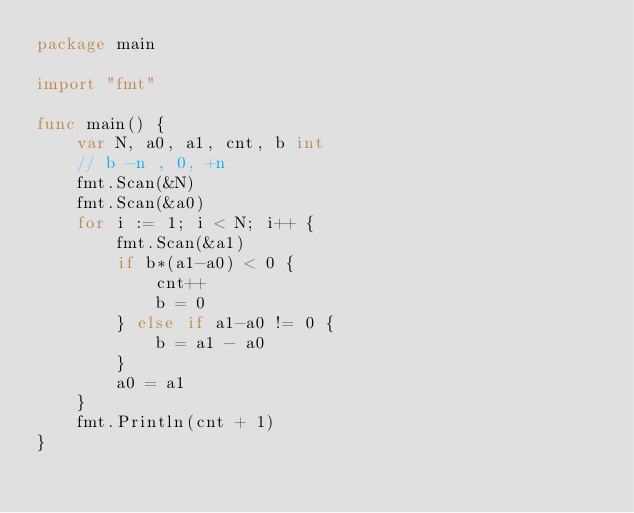<code> <loc_0><loc_0><loc_500><loc_500><_Go_>package main

import "fmt"

func main() {
	var N, a0, a1, cnt, b int
	// b -n , 0, +n
	fmt.Scan(&N)
	fmt.Scan(&a0)
	for i := 1; i < N; i++ {
		fmt.Scan(&a1)
		if b*(a1-a0) < 0 {
			cnt++
			b = 0
		} else if a1-a0 != 0 {
			b = a1 - a0
		}
		a0 = a1
	}
	fmt.Println(cnt + 1)
}
</code> 